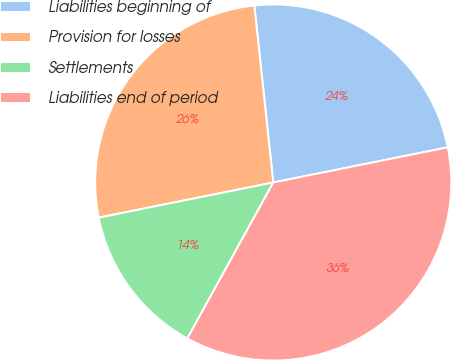Convert chart to OTSL. <chart><loc_0><loc_0><loc_500><loc_500><pie_chart><fcel>Liabilities beginning of<fcel>Provision for losses<fcel>Settlements<fcel>Liabilities end of period<nl><fcel>23.53%<fcel>26.47%<fcel>13.82%<fcel>36.18%<nl></chart> 